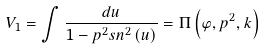<formula> <loc_0><loc_0><loc_500><loc_500>V _ { 1 } = \int \frac { d u } { 1 - p ^ { 2 } s n ^ { 2 } \left ( u \right ) } = \Pi \left ( \varphi , p ^ { 2 } , k \right )</formula> 